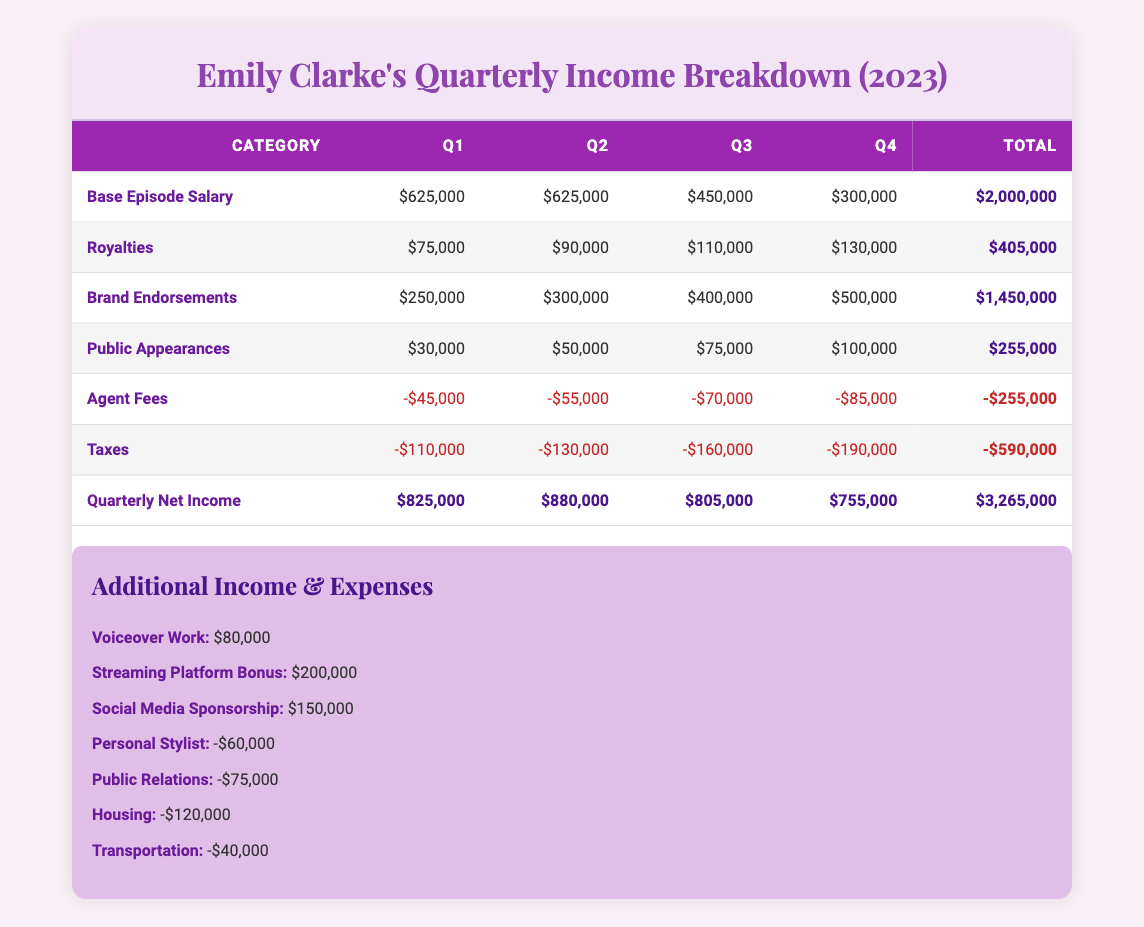What is the total base episode salary earned by Emily Clarke in Q1? In Q1, Emily earned a base episode salary of $125,000 per episode and filmed 5 episodes. The total base episode salary for Q1 is calculated as 125,000 * 5 = 625,000.
Answer: 625000 What were Emily's total royalties for the year? The royalties for each quarter are: Q1 = $75,000, Q2 = $90,000, Q3 = $110,000, and Q4 = $130,000. Adding these amounts gives us 75,000 + 90,000 + 110,000 + 130,000 = 405,000.
Answer: 405000 Did Emily earn more in brand endorsements in Q4 than in Q3? In Q3, Emily's brand endorsements totaled $400,000, while in Q4, they totaled $500,000. Since 500,000 (Q4) is greater than 400,000 (Q3), the answer is yes.
Answer: Yes What is the average net income per quarter for Emily Clarke? The net incomes for each quarter are: Q1 = $825,000, Q2 = $880,000, Q3 = $805,000, Q4 = $755,000. The total net income is 825,000 + 880,000 + 805,000 + 755,000 = 3,265,000. To find the average, we divide by the number of quarters (4), which gives us 3,265,000 / 4 = 816,250.
Answer: 816250 What was Emily's total expenses for personal stylist and public relations in Q2? The personal stylist expense is -$60,000 and the public relations expense is -$75,000. Adding these two expenses gives us -60,000 + (-75,000) = -135,000.
Answer: -135000 How much did Emily earn from additional income sources in total? The additional income includes voiceover work ($80,000), streaming platform bonus ($200,000), and social media sponsorship ($150,000). Summing these gives 80,000 + 200,000 + 150,000 = 430,000.
Answer: 430000 Is the total agent fees for the year greater than the total taxes? The total agent fees are -$255,000, and the total taxes are -$590,000. Since -255,000 is greater than -590,000, the answer is yes.
Answer: Yes What is the total net income for all four quarters combined? The total net income for each quarter is: Q1 = 825,000, Q2 = 880,000, Q3 = 805,000, and Q4 = 755,000. SUMing these gives us 825,000 + 880,000 + 805,000 + 755,000 = 3,265,000.
Answer: 3265000 